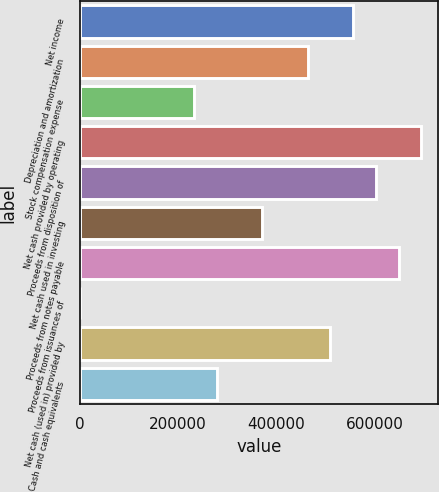Convert chart. <chart><loc_0><loc_0><loc_500><loc_500><bar_chart><fcel>Net income<fcel>Depreciation and amortization<fcel>Stock compensation expense<fcel>Net cash provided by operating<fcel>Proceeds from disposition of<fcel>Net cash used in investing<fcel>Proceeds from notes payable<fcel>Proceeds from issuances of<fcel>Net cash (used in) provided by<fcel>Cash and cash equivalents<nl><fcel>556341<fcel>463721<fcel>232172<fcel>695270<fcel>602651<fcel>371101<fcel>648961<fcel>622<fcel>510031<fcel>278481<nl></chart> 